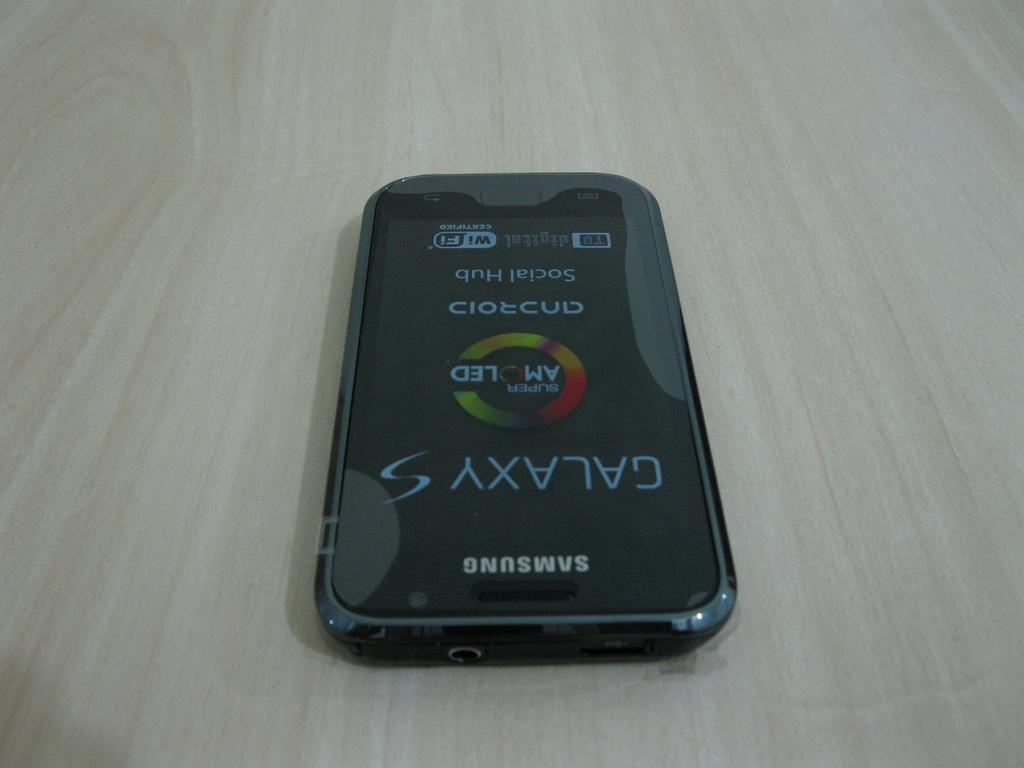<image>
Provide a brief description of the given image. Samsung phone sitting on a table with screen that says Galaxy. 